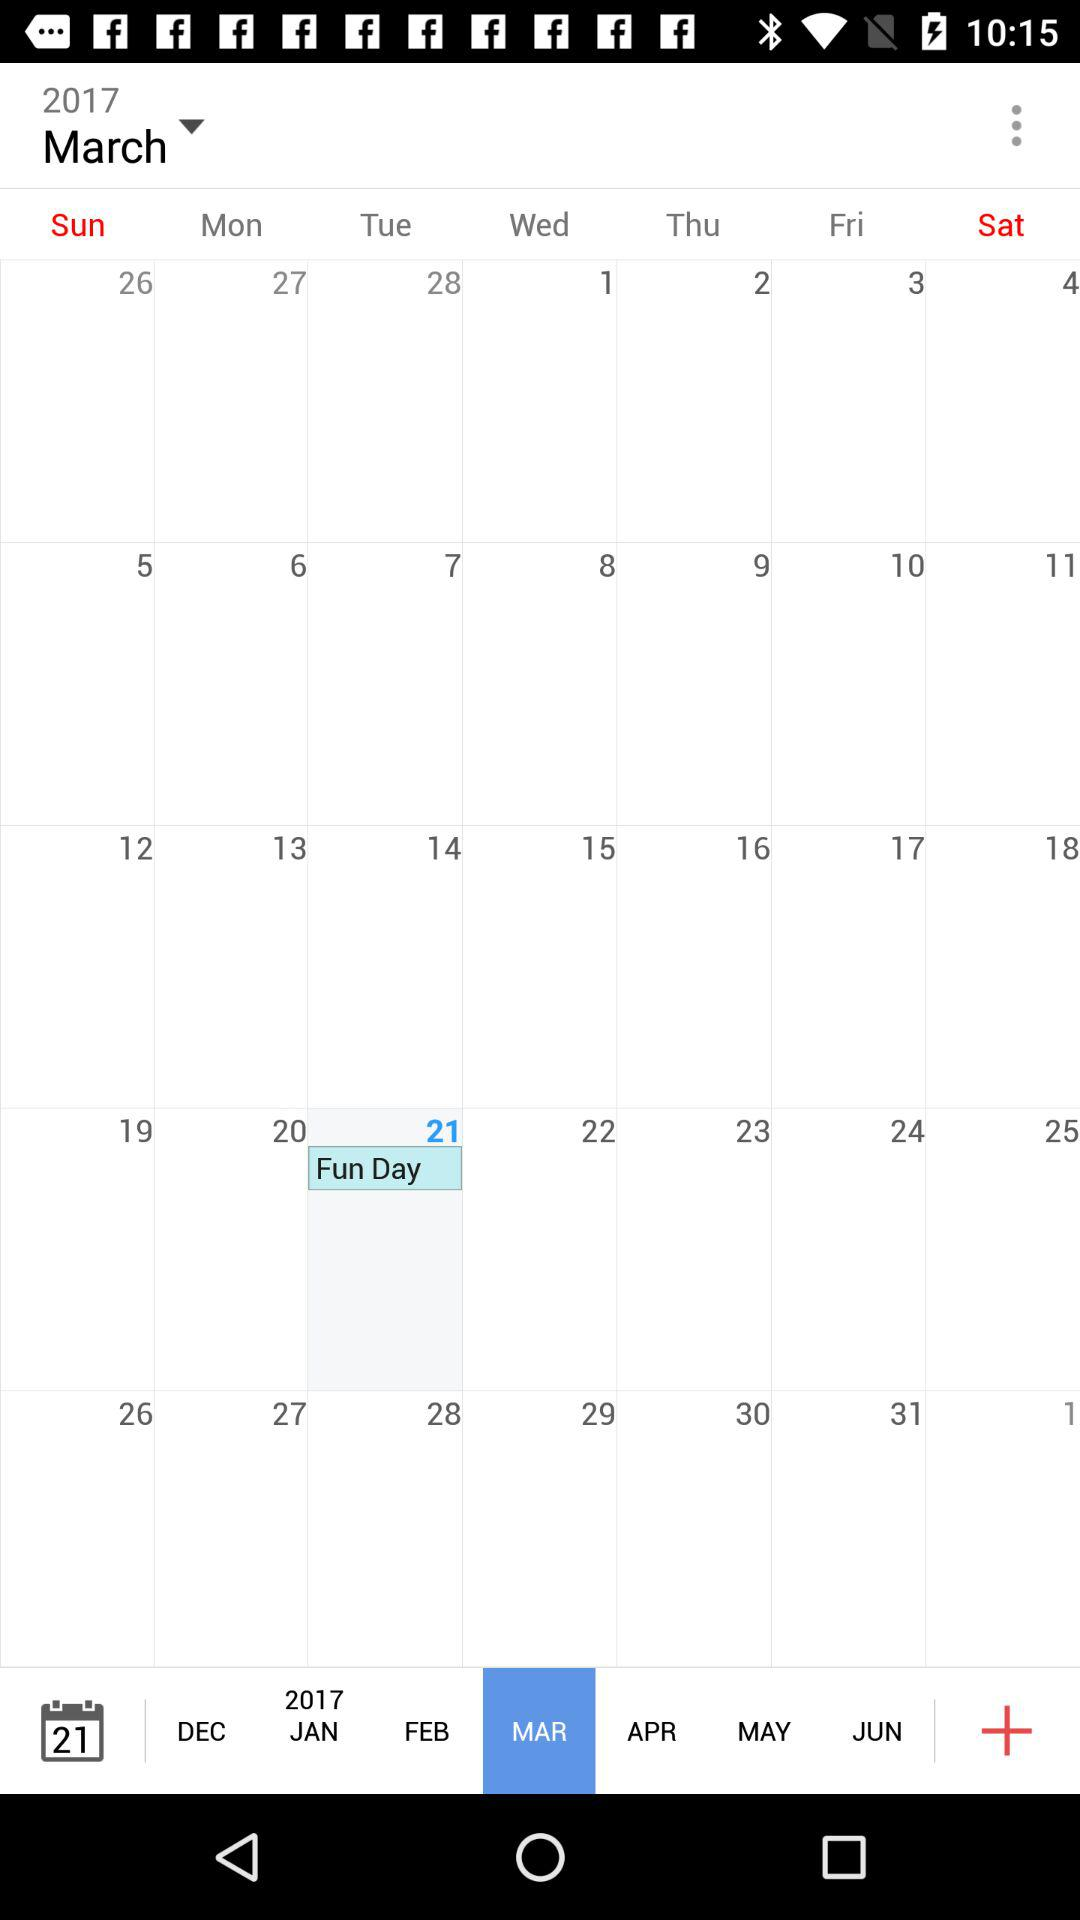Which month is selected? The selected month is March. 